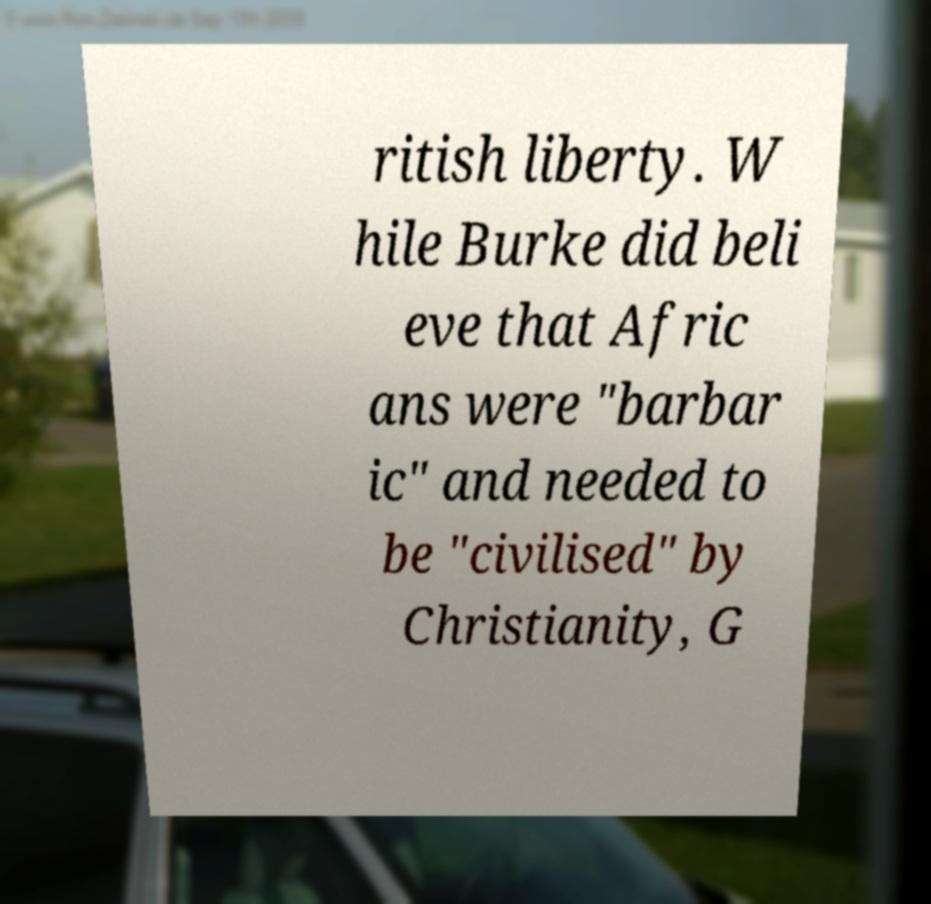Please identify and transcribe the text found in this image. ritish liberty. W hile Burke did beli eve that Afric ans were "barbar ic" and needed to be "civilised" by Christianity, G 